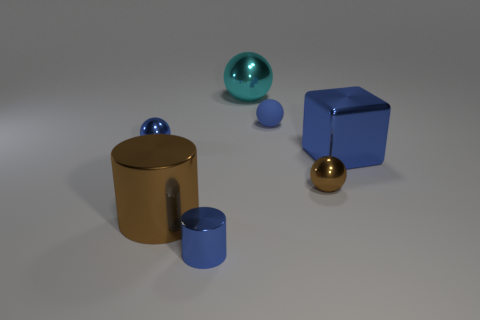There is a small cylinder that is the same color as the shiny block; what is it made of?
Your response must be concise. Metal. How many cyan metal spheres are in front of the blue metal thing that is behind the block?
Your answer should be compact. 0. There is a small sphere that is on the left side of the tiny blue cylinder; is its color the same as the large metallic object that is in front of the big blue shiny thing?
Give a very brief answer. No. What material is the brown cylinder that is the same size as the cyan object?
Offer a very short reply. Metal. What shape is the metal object that is in front of the large metal object left of the big metal thing behind the blue metallic sphere?
Give a very brief answer. Cylinder. What shape is the cyan object that is the same size as the brown metallic cylinder?
Your response must be concise. Sphere. What number of big balls are in front of the brown metallic thing that is left of the metallic sphere that is on the right side of the big cyan ball?
Your answer should be compact. 0. Are there more small spheres in front of the small matte thing than blue things that are to the right of the cyan sphere?
Ensure brevity in your answer.  No. How many big brown things are the same shape as the big cyan thing?
Keep it short and to the point. 0. How many things are metal things that are behind the big cylinder or tiny balls on the left side of the small brown metal thing?
Provide a succinct answer. 5. 